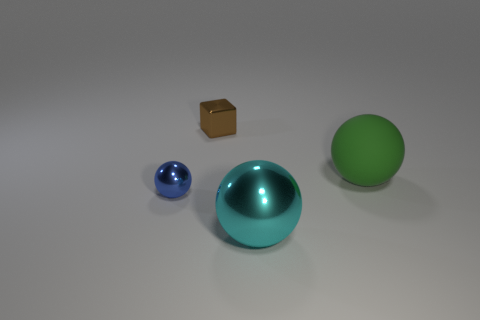Subtract all tiny blue spheres. How many spheres are left? 2 Subtract all cyan spheres. How many spheres are left? 2 Subtract 1 cubes. How many cubes are left? 0 Add 1 green shiny objects. How many green shiny objects exist? 1 Add 3 blue shiny objects. How many objects exist? 7 Subtract 0 red spheres. How many objects are left? 4 Subtract all balls. How many objects are left? 1 Subtract all gray spheres. Subtract all purple cylinders. How many spheres are left? 3 Subtract all brown cubes. How many green balls are left? 1 Subtract all large red matte things. Subtract all small brown metallic cubes. How many objects are left? 3 